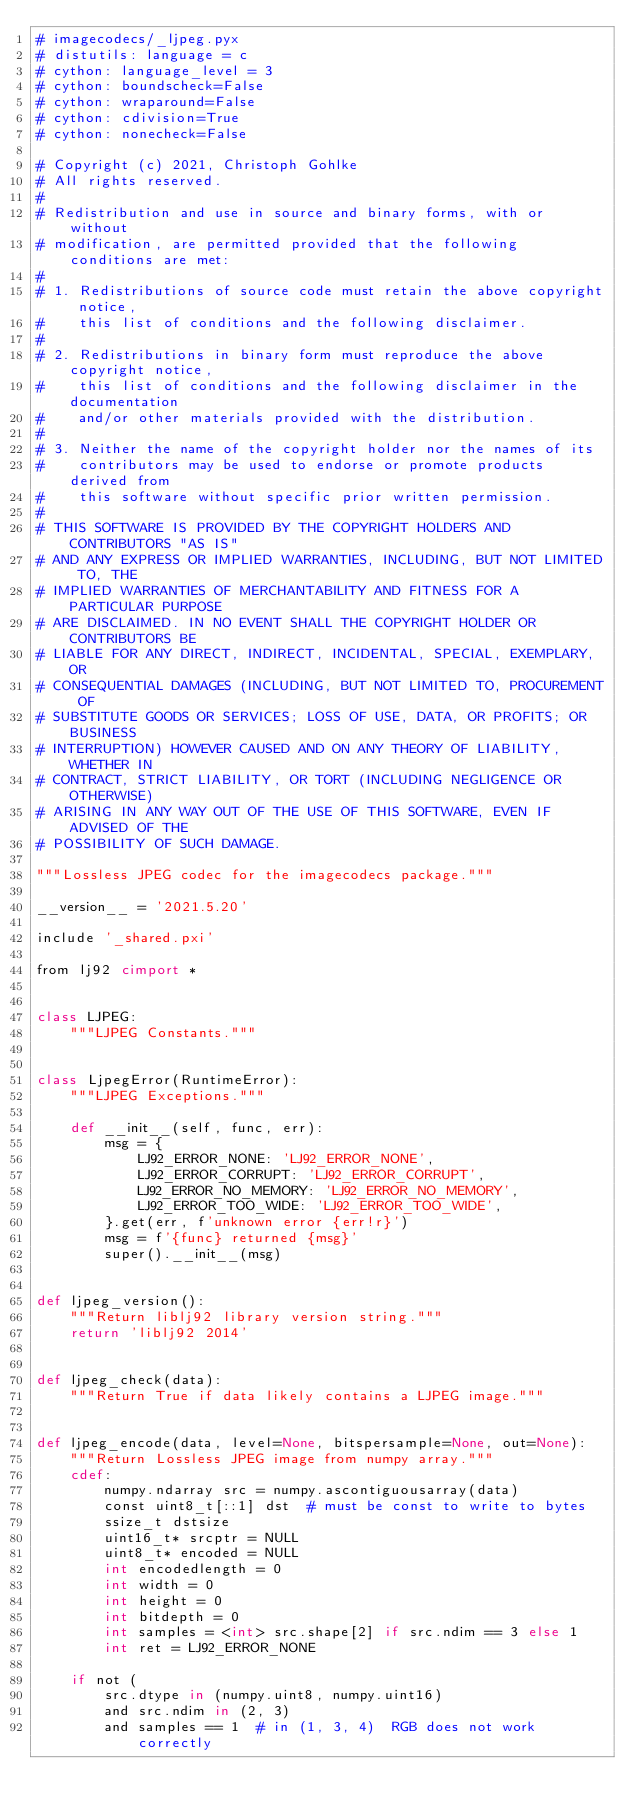<code> <loc_0><loc_0><loc_500><loc_500><_Cython_># imagecodecs/_ljpeg.pyx
# distutils: language = c
# cython: language_level = 3
# cython: boundscheck=False
# cython: wraparound=False
# cython: cdivision=True
# cython: nonecheck=False

# Copyright (c) 2021, Christoph Gohlke
# All rights reserved.
#
# Redistribution and use in source and binary forms, with or without
# modification, are permitted provided that the following conditions are met:
#
# 1. Redistributions of source code must retain the above copyright notice,
#    this list of conditions and the following disclaimer.
#
# 2. Redistributions in binary form must reproduce the above copyright notice,
#    this list of conditions and the following disclaimer in the documentation
#    and/or other materials provided with the distribution.
#
# 3. Neither the name of the copyright holder nor the names of its
#    contributors may be used to endorse or promote products derived from
#    this software without specific prior written permission.
#
# THIS SOFTWARE IS PROVIDED BY THE COPYRIGHT HOLDERS AND CONTRIBUTORS "AS IS"
# AND ANY EXPRESS OR IMPLIED WARRANTIES, INCLUDING, BUT NOT LIMITED TO, THE
# IMPLIED WARRANTIES OF MERCHANTABILITY AND FITNESS FOR A PARTICULAR PURPOSE
# ARE DISCLAIMED. IN NO EVENT SHALL THE COPYRIGHT HOLDER OR CONTRIBUTORS BE
# LIABLE FOR ANY DIRECT, INDIRECT, INCIDENTAL, SPECIAL, EXEMPLARY, OR
# CONSEQUENTIAL DAMAGES (INCLUDING, BUT NOT LIMITED TO, PROCUREMENT OF
# SUBSTITUTE GOODS OR SERVICES; LOSS OF USE, DATA, OR PROFITS; OR BUSINESS
# INTERRUPTION) HOWEVER CAUSED AND ON ANY THEORY OF LIABILITY, WHETHER IN
# CONTRACT, STRICT LIABILITY, OR TORT (INCLUDING NEGLIGENCE OR OTHERWISE)
# ARISING IN ANY WAY OUT OF THE USE OF THIS SOFTWARE, EVEN IF ADVISED OF THE
# POSSIBILITY OF SUCH DAMAGE.

"""Lossless JPEG codec for the imagecodecs package."""

__version__ = '2021.5.20'

include '_shared.pxi'

from lj92 cimport *


class LJPEG:
    """LJPEG Constants."""


class LjpegError(RuntimeError):
    """LJPEG Exceptions."""

    def __init__(self, func, err):
        msg = {
            LJ92_ERROR_NONE: 'LJ92_ERROR_NONE',
            LJ92_ERROR_CORRUPT: 'LJ92_ERROR_CORRUPT',
            LJ92_ERROR_NO_MEMORY: 'LJ92_ERROR_NO_MEMORY',
            LJ92_ERROR_TOO_WIDE: 'LJ92_ERROR_TOO_WIDE',
        }.get(err, f'unknown error {err!r}')
        msg = f'{func} returned {msg}'
        super().__init__(msg)


def ljpeg_version():
    """Return liblj92 library version string."""
    return 'liblj92 2014'


def ljpeg_check(data):
    """Return True if data likely contains a LJPEG image."""


def ljpeg_encode(data, level=None, bitspersample=None, out=None):
    """Return Lossless JPEG image from numpy array."""
    cdef:
        numpy.ndarray src = numpy.ascontiguousarray(data)
        const uint8_t[::1] dst  # must be const to write to bytes
        ssize_t dstsize
        uint16_t* srcptr = NULL
        uint8_t* encoded = NULL
        int encodedlength = 0
        int width = 0
        int height = 0
        int bitdepth = 0
        int samples = <int> src.shape[2] if src.ndim == 3 else 1
        int ret = LJ92_ERROR_NONE

    if not (
        src.dtype in (numpy.uint8, numpy.uint16)
        and src.ndim in (2, 3)
        and samples == 1  # in (1, 3, 4)  RGB does not work correctly</code> 